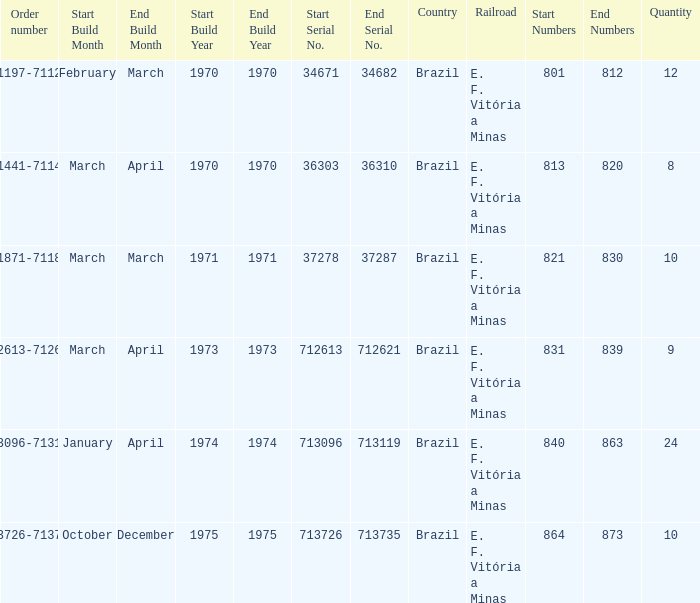What is the quantity of railroads numbered 864-873? 1.0. 